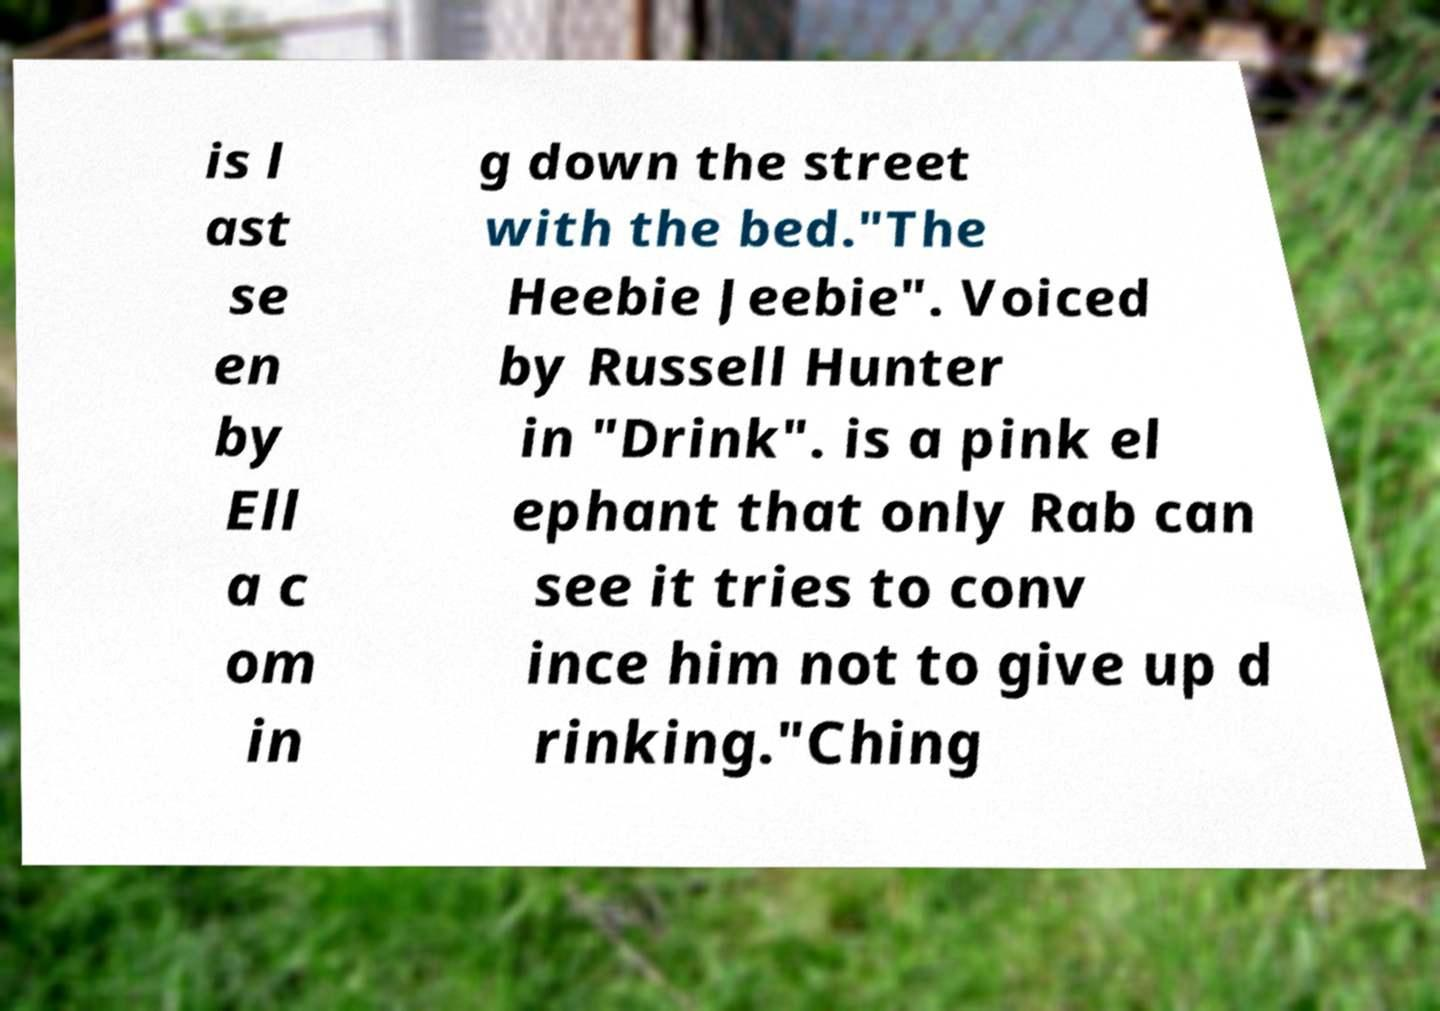Please read and relay the text visible in this image. What does it say? is l ast se en by Ell a c om in g down the street with the bed."The Heebie Jeebie". Voiced by Russell Hunter in "Drink". is a pink el ephant that only Rab can see it tries to conv ince him not to give up d rinking."Ching 